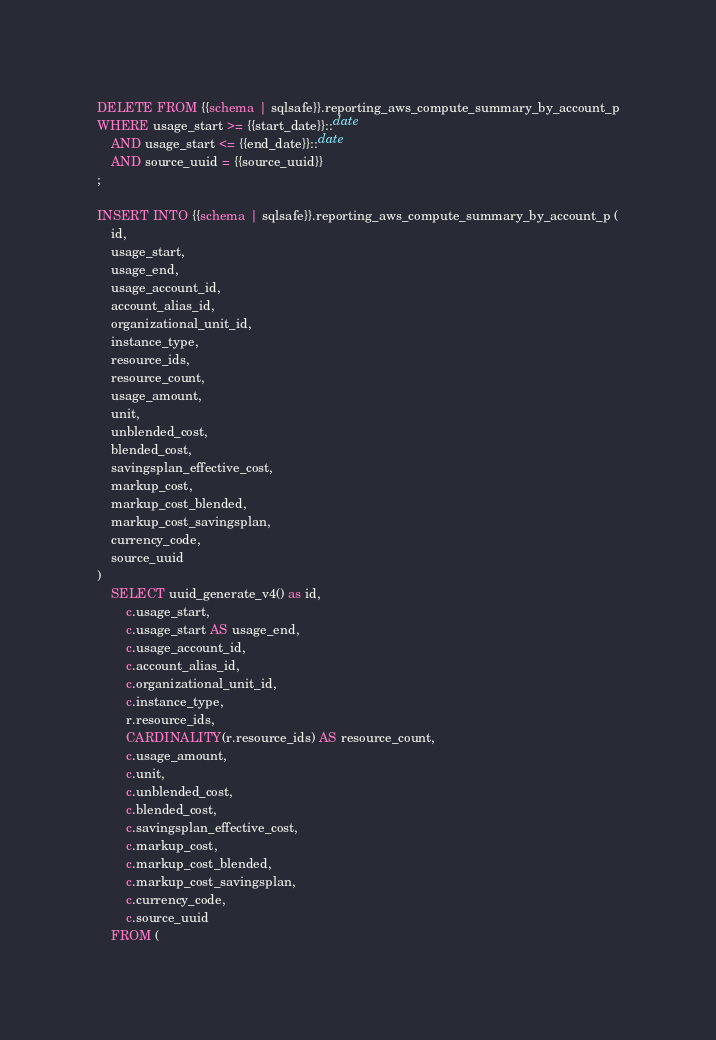<code> <loc_0><loc_0><loc_500><loc_500><_SQL_>DELETE FROM {{schema | sqlsafe}}.reporting_aws_compute_summary_by_account_p
WHERE usage_start >= {{start_date}}::date
    AND usage_start <= {{end_date}}::date
    AND source_uuid = {{source_uuid}}
;

INSERT INTO {{schema | sqlsafe}}.reporting_aws_compute_summary_by_account_p (
    id,
    usage_start,
    usage_end,
    usage_account_id,
    account_alias_id,
    organizational_unit_id,
    instance_type,
    resource_ids,
    resource_count,
    usage_amount,
    unit,
    unblended_cost,
    blended_cost,
    savingsplan_effective_cost,
    markup_cost,
    markup_cost_blended,
    markup_cost_savingsplan,
    currency_code,
    source_uuid
)
    SELECT uuid_generate_v4() as id,
        c.usage_start,
        c.usage_start AS usage_end,
        c.usage_account_id,
        c.account_alias_id,
        c.organizational_unit_id,
        c.instance_type,
        r.resource_ids,
        CARDINALITY(r.resource_ids) AS resource_count,
        c.usage_amount,
        c.unit,
        c.unblended_cost,
        c.blended_cost,
        c.savingsplan_effective_cost,
        c.markup_cost,
        c.markup_cost_blended,
        c.markup_cost_savingsplan,
        c.currency_code,
        c.source_uuid
    FROM (</code> 